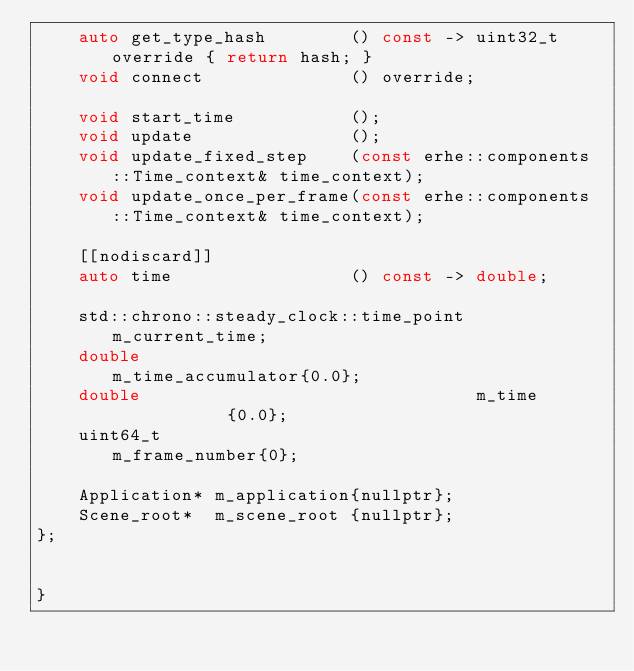<code> <loc_0><loc_0><loc_500><loc_500><_C++_>    auto get_type_hash        () const -> uint32_t override { return hash; }
    void connect              () override;

    void start_time           ();
    void update               ();
    void update_fixed_step    (const erhe::components::Time_context& time_context);
    void update_once_per_frame(const erhe::components::Time_context& time_context);

    [[nodiscard]]
    auto time                 () const -> double;

    std::chrono::steady_clock::time_point m_current_time;
    double                                m_time_accumulator{0.0};
    double                                m_time            {0.0};
    uint64_t                              m_frame_number{0};

    Application* m_application{nullptr};
    Scene_root*  m_scene_root {nullptr};
};  
   

}
</code> 